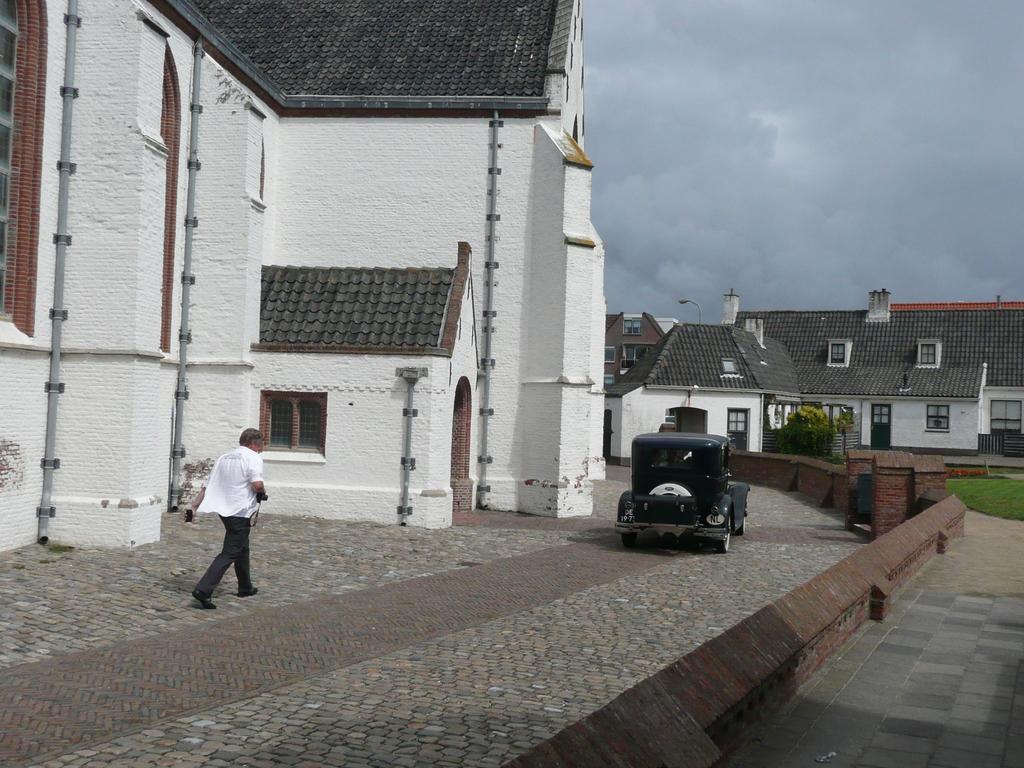Could you give a brief overview of what you see in this image? In the foreground I can see a person and a vehicle on the road. In the background I can see a building, houses, trees, grass, fence and windows. On the top right I can see the sky. This image is taken during a day. 